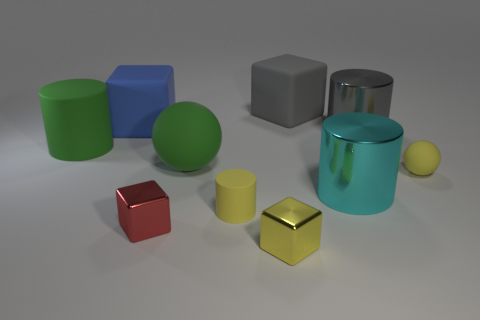Subtract all large green matte cylinders. How many cylinders are left? 3 Subtract all cyan cylinders. How many cylinders are left? 3 Subtract all balls. How many objects are left? 8 Subtract 2 cylinders. How many cylinders are left? 2 Subtract all cyan cylinders. How many yellow cubes are left? 1 Subtract all gray cubes. Subtract all large gray metallic things. How many objects are left? 8 Add 8 tiny shiny blocks. How many tiny shiny blocks are left? 10 Add 10 big purple blocks. How many big purple blocks exist? 10 Subtract 1 red cubes. How many objects are left? 9 Subtract all blue cubes. Subtract all yellow cylinders. How many cubes are left? 3 